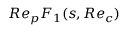<formula> <loc_0><loc_0><loc_500><loc_500>R e _ { p } F _ { 1 } ( s , R e _ { c } )</formula> 